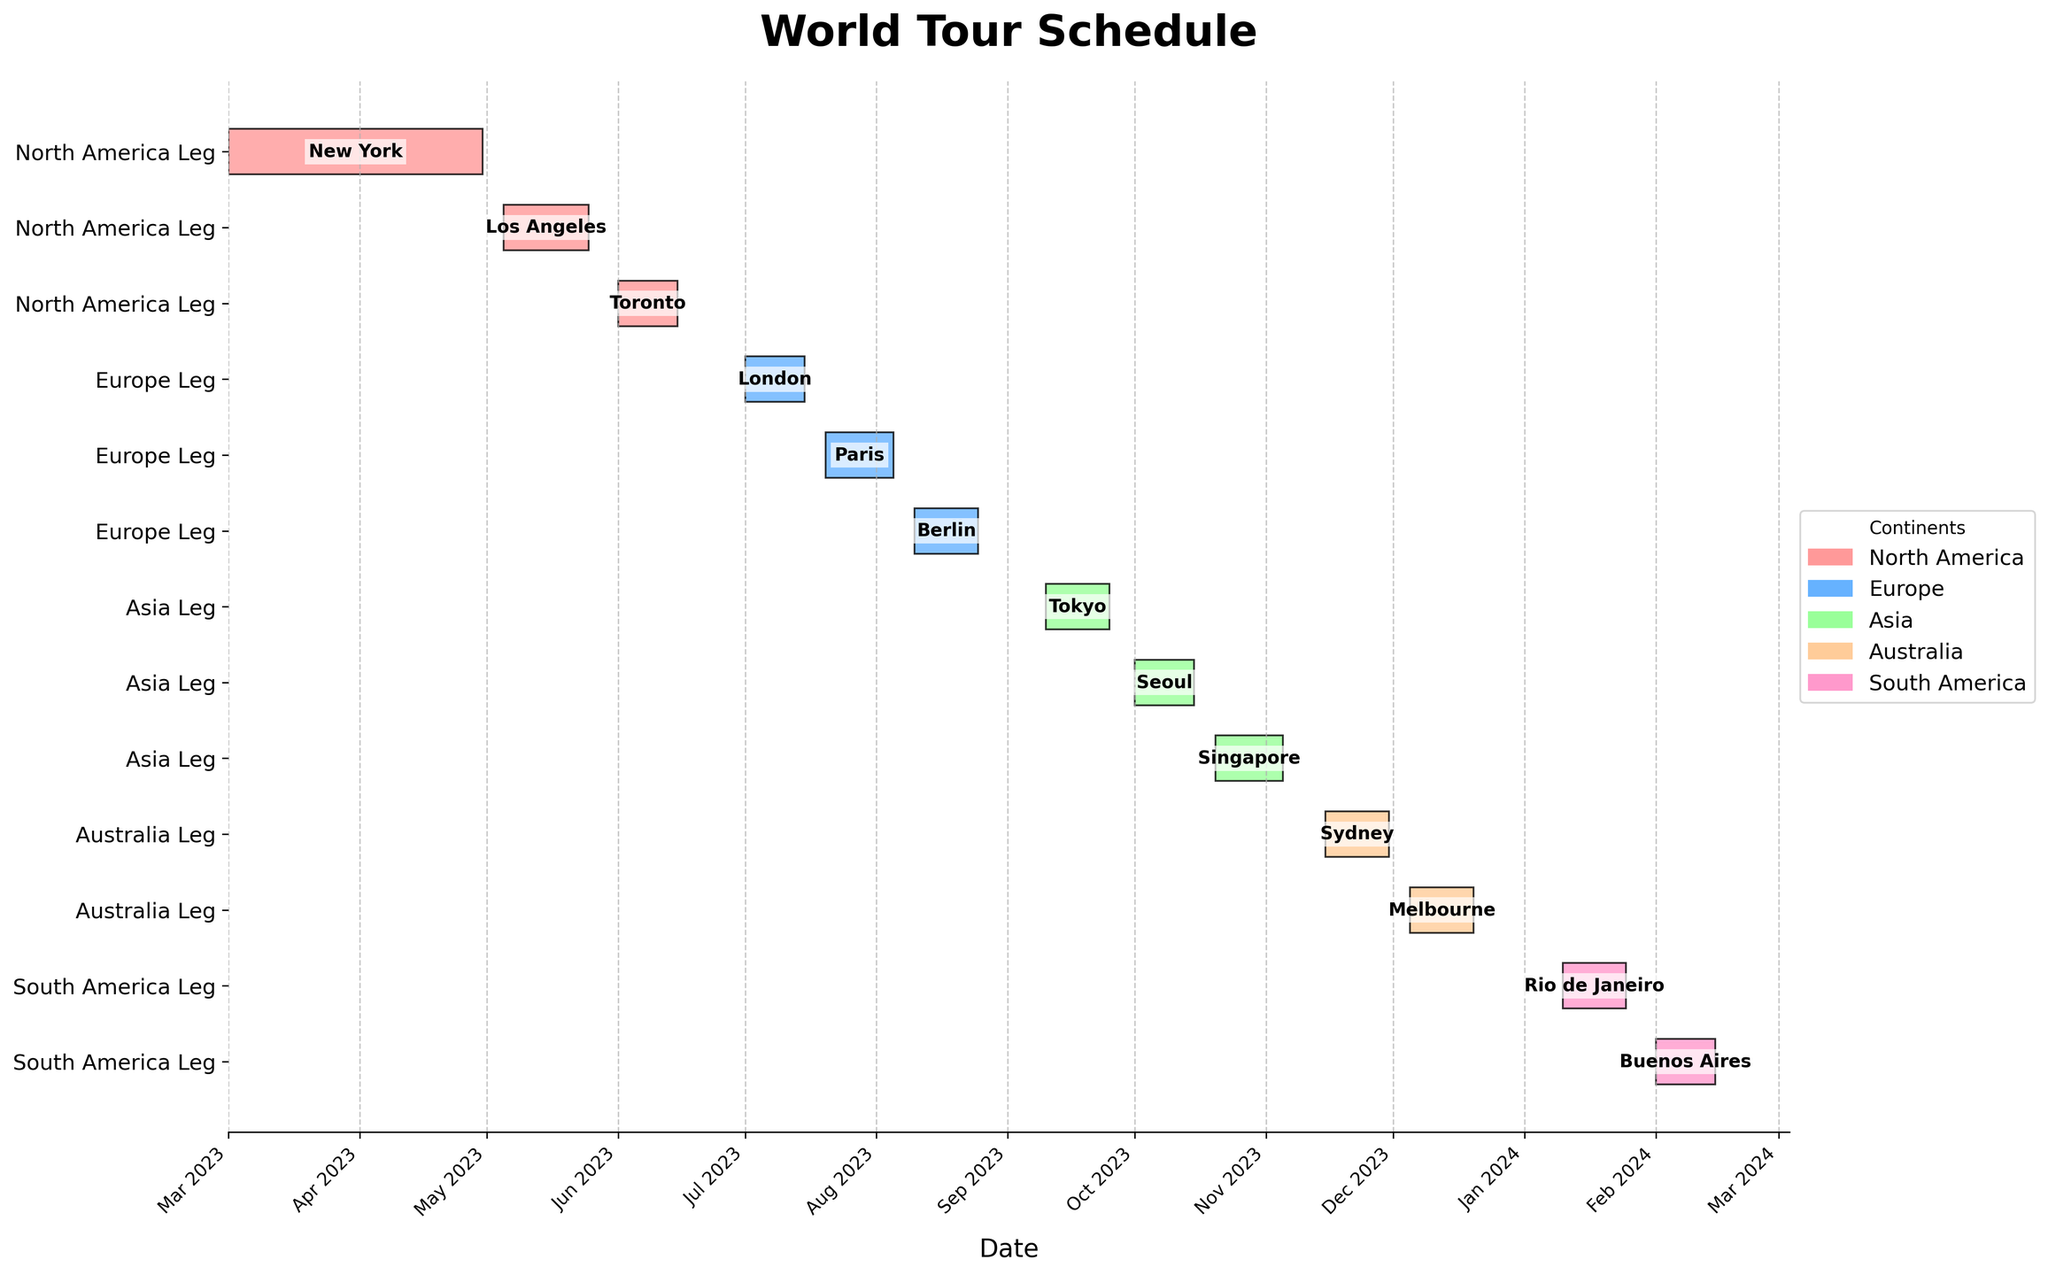What's the title of the figure? The title is written at the top of the figure.
Answer: World Tour Schedule How many continents are included in the world tour? The legend of the figure shows the unique continents involved.
Answer: 5 Which city does the tour start in? The bars and the labels on the leftmost side show the cities and their start dates.
Answer: New York For how many days does the tour in London last? The length of the bar labeled "London" represents the duration.
Answer: 15 days Which continent has the most number of cities in the tour? Count the occurrences of each continent in the y-axis labels.
Answer: North America How long does the tour in Asia last in total? Sum up the durations of the bars under the Asia section.
Answer: 45 days Which tour leg immediately follows the Sydney tour? Review the end date of Sydney and identify the next city's bar that follows.
Answer: Melbourne How does the duration of the Paris leg compare to the Berlin leg? Compare the lengths of the bars for Paris and Berlin.
Answer: Berlin is 5 days longer What is the longest continuous tour leg in a single city? Check the duration of each city and see which is the longest.
Answer: Singapore (16 days) How many months does the entire tour span? Note the start date of the first tour and the end date of the last, then count the months in between.
Answer: 12 months 